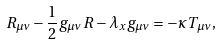Convert formula to latex. <formula><loc_0><loc_0><loc_500><loc_500>R _ { \mu \nu } - \frac { 1 } { 2 } g _ { \mu \nu } R - \lambda _ { x } g _ { \mu \nu } = - \kappa T _ { \mu \nu } ,</formula> 